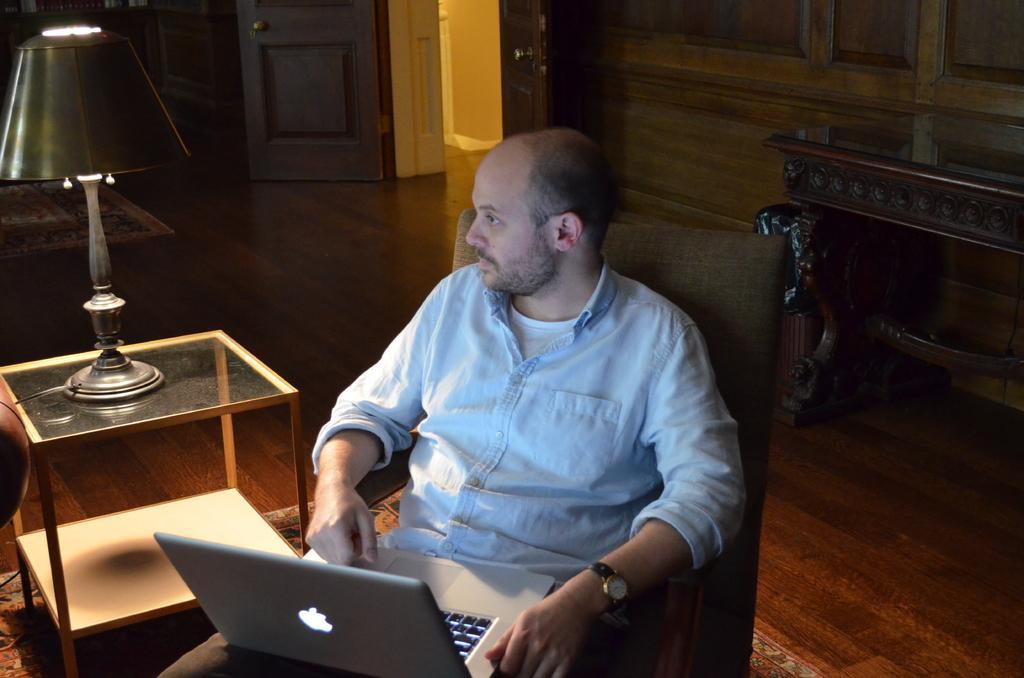In one or two sentences, can you explain what this image depicts? In this Image I see a man who is sitting on chair and there is a laptop on him and there is a table side to him on which there is a lamp. In the background I see the door. 